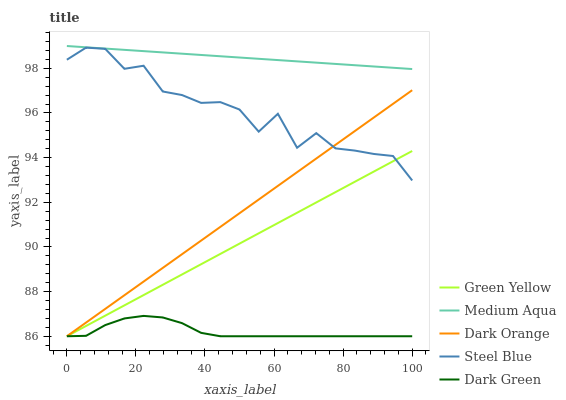Does Green Yellow have the minimum area under the curve?
Answer yes or no. No. Does Green Yellow have the maximum area under the curve?
Answer yes or no. No. Is Green Yellow the smoothest?
Answer yes or no. No. Is Green Yellow the roughest?
Answer yes or no. No. Does Medium Aqua have the lowest value?
Answer yes or no. No. Does Green Yellow have the highest value?
Answer yes or no. No. Is Dark Orange less than Medium Aqua?
Answer yes or no. Yes. Is Medium Aqua greater than Green Yellow?
Answer yes or no. Yes. Does Dark Orange intersect Medium Aqua?
Answer yes or no. No. 